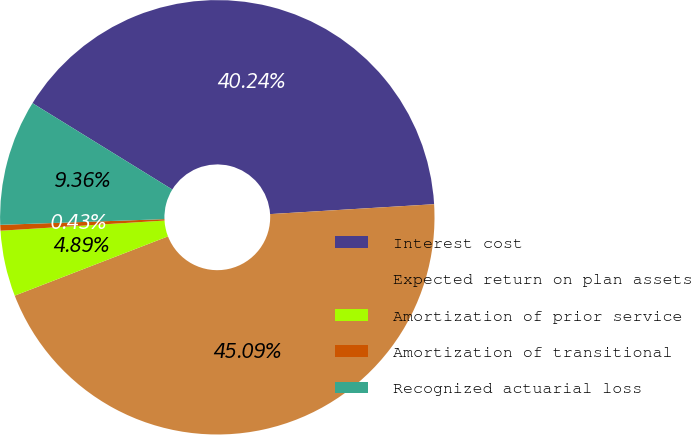Convert chart. <chart><loc_0><loc_0><loc_500><loc_500><pie_chart><fcel>Interest cost<fcel>Expected return on plan assets<fcel>Amortization of prior service<fcel>Amortization of transitional<fcel>Recognized actuarial loss<nl><fcel>40.24%<fcel>45.09%<fcel>4.89%<fcel>0.43%<fcel>9.36%<nl></chart> 